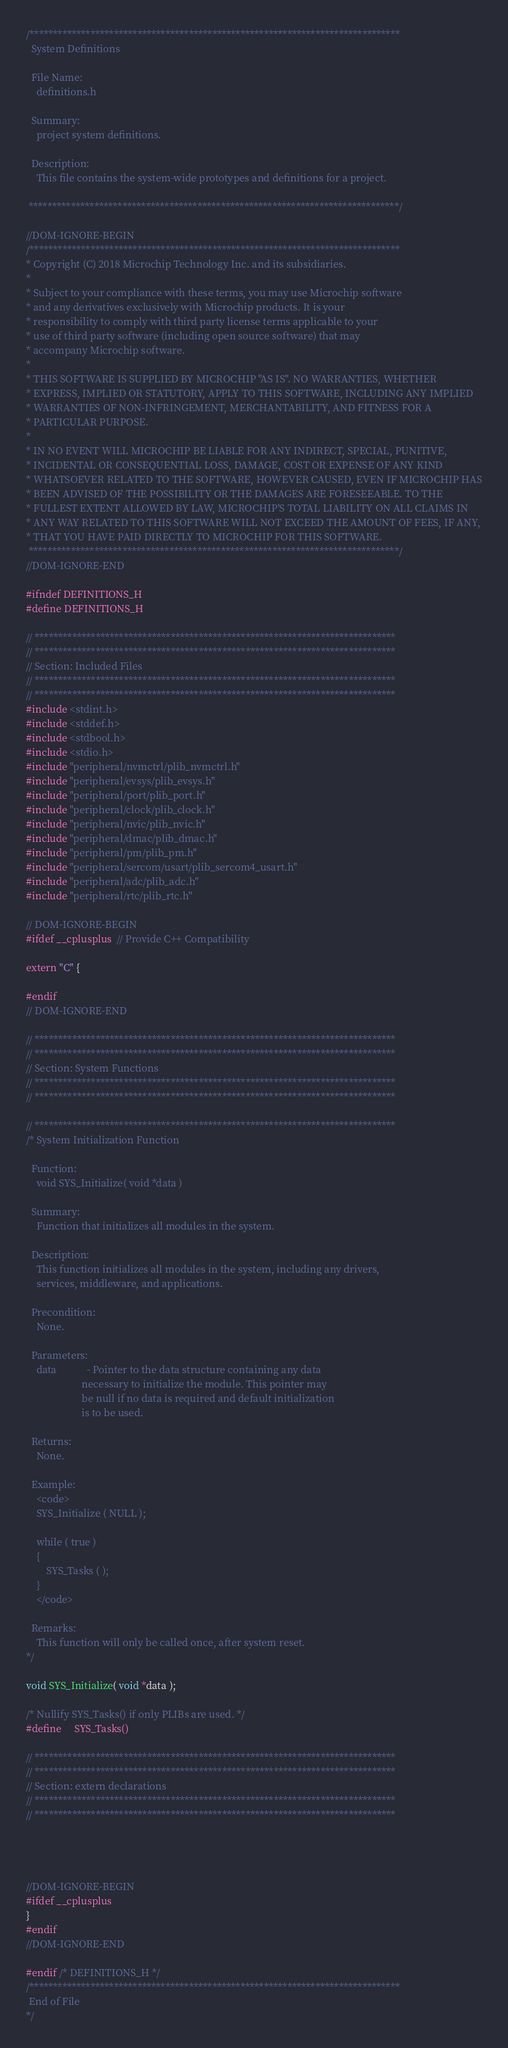Convert code to text. <code><loc_0><loc_0><loc_500><loc_500><_C_>/*******************************************************************************
  System Definitions

  File Name:
    definitions.h

  Summary:
    project system definitions.

  Description:
    This file contains the system-wide prototypes and definitions for a project.

 *******************************************************************************/

//DOM-IGNORE-BEGIN
/*******************************************************************************
* Copyright (C) 2018 Microchip Technology Inc. and its subsidiaries.
*
* Subject to your compliance with these terms, you may use Microchip software
* and any derivatives exclusively with Microchip products. It is your
* responsibility to comply with third party license terms applicable to your
* use of third party software (including open source software) that may
* accompany Microchip software.
*
* THIS SOFTWARE IS SUPPLIED BY MICROCHIP "AS IS". NO WARRANTIES, WHETHER
* EXPRESS, IMPLIED OR STATUTORY, APPLY TO THIS SOFTWARE, INCLUDING ANY IMPLIED
* WARRANTIES OF NON-INFRINGEMENT, MERCHANTABILITY, AND FITNESS FOR A
* PARTICULAR PURPOSE.
*
* IN NO EVENT WILL MICROCHIP BE LIABLE FOR ANY INDIRECT, SPECIAL, PUNITIVE,
* INCIDENTAL OR CONSEQUENTIAL LOSS, DAMAGE, COST OR EXPENSE OF ANY KIND
* WHATSOEVER RELATED TO THE SOFTWARE, HOWEVER CAUSED, EVEN IF MICROCHIP HAS
* BEEN ADVISED OF THE POSSIBILITY OR THE DAMAGES ARE FORESEEABLE. TO THE
* FULLEST EXTENT ALLOWED BY LAW, MICROCHIP'S TOTAL LIABILITY ON ALL CLAIMS IN
* ANY WAY RELATED TO THIS SOFTWARE WILL NOT EXCEED THE AMOUNT OF FEES, IF ANY,
* THAT YOU HAVE PAID DIRECTLY TO MICROCHIP FOR THIS SOFTWARE.
 *******************************************************************************/
//DOM-IGNORE-END

#ifndef DEFINITIONS_H
#define DEFINITIONS_H

// *****************************************************************************
// *****************************************************************************
// Section: Included Files
// *****************************************************************************
// *****************************************************************************
#include <stdint.h>
#include <stddef.h>
#include <stdbool.h>
#include <stdio.h>
#include "peripheral/nvmctrl/plib_nvmctrl.h"
#include "peripheral/evsys/plib_evsys.h"
#include "peripheral/port/plib_port.h"
#include "peripheral/clock/plib_clock.h"
#include "peripheral/nvic/plib_nvic.h"
#include "peripheral/dmac/plib_dmac.h"
#include "peripheral/pm/plib_pm.h"
#include "peripheral/sercom/usart/plib_sercom4_usart.h"
#include "peripheral/adc/plib_adc.h"
#include "peripheral/rtc/plib_rtc.h"

// DOM-IGNORE-BEGIN
#ifdef __cplusplus  // Provide C++ Compatibility

extern "C" {

#endif
// DOM-IGNORE-END

// *****************************************************************************
// *****************************************************************************
// Section: System Functions
// *****************************************************************************
// *****************************************************************************

// *****************************************************************************
/* System Initialization Function

  Function:
    void SYS_Initialize( void *data )

  Summary:
    Function that initializes all modules in the system.

  Description:
    This function initializes all modules in the system, including any drivers,
    services, middleware, and applications.

  Precondition:
    None.

  Parameters:
    data            - Pointer to the data structure containing any data
                      necessary to initialize the module. This pointer may
                      be null if no data is required and default initialization
                      is to be used.

  Returns:
    None.

  Example:
    <code>
    SYS_Initialize ( NULL );

    while ( true )
    {
        SYS_Tasks ( );
    }
    </code>

  Remarks:
    This function will only be called once, after system reset.
*/

void SYS_Initialize( void *data );

/* Nullify SYS_Tasks() if only PLIBs are used. */
#define     SYS_Tasks()

// *****************************************************************************
// *****************************************************************************
// Section: extern declarations
// *****************************************************************************
// *****************************************************************************




//DOM-IGNORE-BEGIN
#ifdef __cplusplus
}
#endif
//DOM-IGNORE-END

#endif /* DEFINITIONS_H */
/*******************************************************************************
 End of File
*/

</code> 